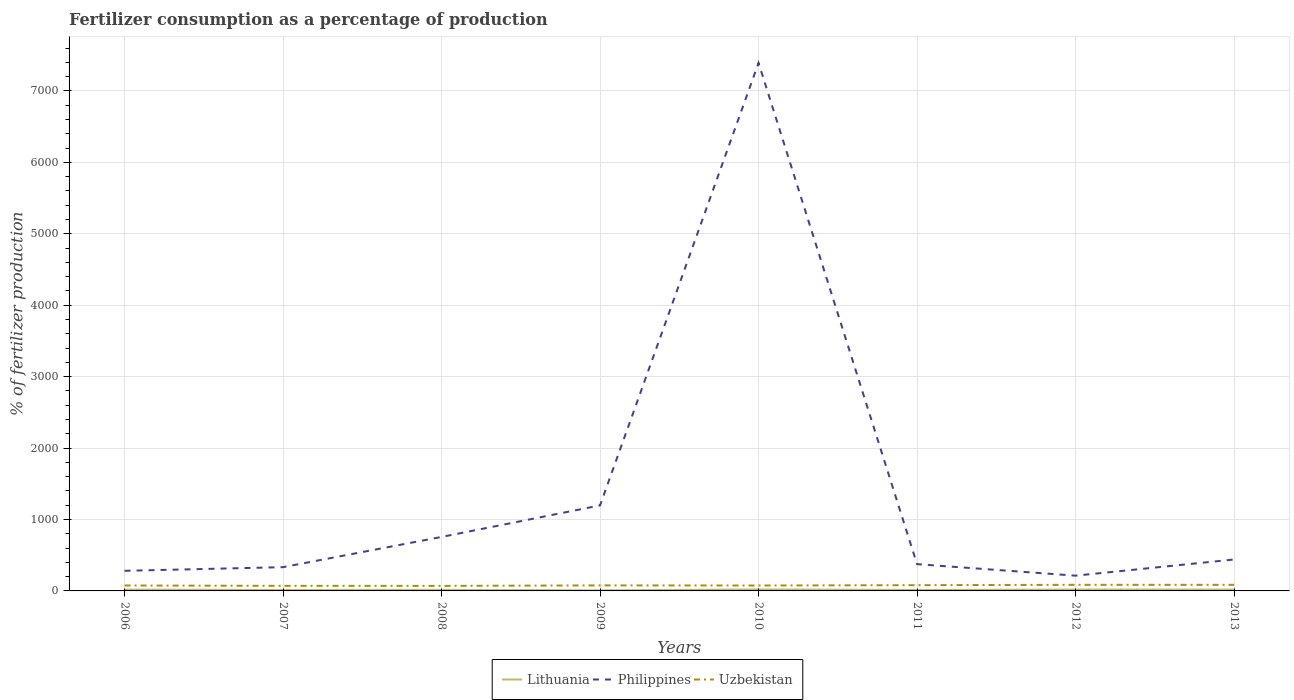How many different coloured lines are there?
Provide a short and direct response. 3. Does the line corresponding to Uzbekistan intersect with the line corresponding to Lithuania?
Keep it short and to the point. No. Is the number of lines equal to the number of legend labels?
Offer a very short reply. Yes. Across all years, what is the maximum percentage of fertilizers consumed in Lithuania?
Keep it short and to the point. 8.24. In which year was the percentage of fertilizers consumed in Philippines maximum?
Your response must be concise. 2012. What is the total percentage of fertilizers consumed in Uzbekistan in the graph?
Offer a very short reply. 0.17. What is the difference between the highest and the second highest percentage of fertilizers consumed in Lithuania?
Provide a succinct answer. 12.39. How many lines are there?
Your response must be concise. 3. How many years are there in the graph?
Ensure brevity in your answer.  8. Does the graph contain grids?
Offer a very short reply. Yes. How are the legend labels stacked?
Keep it short and to the point. Horizontal. What is the title of the graph?
Ensure brevity in your answer.  Fertilizer consumption as a percentage of production. What is the label or title of the Y-axis?
Provide a short and direct response. % of fertilizer production. What is the % of fertilizer production of Lithuania in 2006?
Ensure brevity in your answer.  18.42. What is the % of fertilizer production in Philippines in 2006?
Provide a succinct answer. 281.59. What is the % of fertilizer production in Uzbekistan in 2006?
Your answer should be compact. 76.02. What is the % of fertilizer production in Lithuania in 2007?
Your answer should be compact. 13.91. What is the % of fertilizer production in Philippines in 2007?
Make the answer very short. 332.59. What is the % of fertilizer production in Uzbekistan in 2007?
Give a very brief answer. 70.8. What is the % of fertilizer production in Lithuania in 2008?
Provide a succinct answer. 14.66. What is the % of fertilizer production of Philippines in 2008?
Your response must be concise. 755.74. What is the % of fertilizer production in Uzbekistan in 2008?
Ensure brevity in your answer.  70.18. What is the % of fertilizer production in Lithuania in 2009?
Keep it short and to the point. 8.24. What is the % of fertilizer production of Philippines in 2009?
Your answer should be compact. 1197.15. What is the % of fertilizer production in Uzbekistan in 2009?
Offer a very short reply. 77.46. What is the % of fertilizer production in Lithuania in 2010?
Your answer should be compact. 20.63. What is the % of fertilizer production in Philippines in 2010?
Offer a very short reply. 7391.18. What is the % of fertilizer production in Uzbekistan in 2010?
Give a very brief answer. 75.64. What is the % of fertilizer production in Lithuania in 2011?
Your answer should be compact. 13.61. What is the % of fertilizer production of Philippines in 2011?
Offer a very short reply. 374.92. What is the % of fertilizer production in Uzbekistan in 2011?
Provide a succinct answer. 80.55. What is the % of fertilizer production of Lithuania in 2012?
Offer a very short reply. 18.58. What is the % of fertilizer production in Philippines in 2012?
Your response must be concise. 213.56. What is the % of fertilizer production of Uzbekistan in 2012?
Offer a terse response. 85.6. What is the % of fertilizer production in Lithuania in 2013?
Provide a short and direct response. 18.16. What is the % of fertilizer production of Philippines in 2013?
Provide a short and direct response. 440.02. What is the % of fertilizer production in Uzbekistan in 2013?
Provide a succinct answer. 85.44. Across all years, what is the maximum % of fertilizer production of Lithuania?
Your response must be concise. 20.63. Across all years, what is the maximum % of fertilizer production in Philippines?
Your answer should be very brief. 7391.18. Across all years, what is the maximum % of fertilizer production of Uzbekistan?
Ensure brevity in your answer.  85.6. Across all years, what is the minimum % of fertilizer production of Lithuania?
Keep it short and to the point. 8.24. Across all years, what is the minimum % of fertilizer production in Philippines?
Your answer should be compact. 213.56. Across all years, what is the minimum % of fertilizer production in Uzbekistan?
Your answer should be very brief. 70.18. What is the total % of fertilizer production in Lithuania in the graph?
Give a very brief answer. 126.19. What is the total % of fertilizer production in Philippines in the graph?
Your response must be concise. 1.10e+04. What is the total % of fertilizer production in Uzbekistan in the graph?
Your response must be concise. 621.7. What is the difference between the % of fertilizer production of Lithuania in 2006 and that in 2007?
Your response must be concise. 4.51. What is the difference between the % of fertilizer production of Philippines in 2006 and that in 2007?
Ensure brevity in your answer.  -51. What is the difference between the % of fertilizer production of Uzbekistan in 2006 and that in 2007?
Offer a terse response. 5.21. What is the difference between the % of fertilizer production of Lithuania in 2006 and that in 2008?
Give a very brief answer. 3.76. What is the difference between the % of fertilizer production of Philippines in 2006 and that in 2008?
Offer a terse response. -474.15. What is the difference between the % of fertilizer production of Uzbekistan in 2006 and that in 2008?
Your answer should be compact. 5.83. What is the difference between the % of fertilizer production of Lithuania in 2006 and that in 2009?
Your answer should be very brief. 10.18. What is the difference between the % of fertilizer production of Philippines in 2006 and that in 2009?
Your response must be concise. -915.56. What is the difference between the % of fertilizer production of Uzbekistan in 2006 and that in 2009?
Your answer should be compact. -1.45. What is the difference between the % of fertilizer production of Lithuania in 2006 and that in 2010?
Keep it short and to the point. -2.21. What is the difference between the % of fertilizer production of Philippines in 2006 and that in 2010?
Give a very brief answer. -7109.59. What is the difference between the % of fertilizer production in Uzbekistan in 2006 and that in 2010?
Make the answer very short. 0.37. What is the difference between the % of fertilizer production of Lithuania in 2006 and that in 2011?
Give a very brief answer. 4.81. What is the difference between the % of fertilizer production in Philippines in 2006 and that in 2011?
Offer a terse response. -93.33. What is the difference between the % of fertilizer production in Uzbekistan in 2006 and that in 2011?
Your answer should be very brief. -4.54. What is the difference between the % of fertilizer production in Lithuania in 2006 and that in 2012?
Offer a very short reply. -0.16. What is the difference between the % of fertilizer production of Philippines in 2006 and that in 2012?
Provide a succinct answer. 68.03. What is the difference between the % of fertilizer production in Uzbekistan in 2006 and that in 2012?
Provide a succinct answer. -9.59. What is the difference between the % of fertilizer production in Lithuania in 2006 and that in 2013?
Ensure brevity in your answer.  0.26. What is the difference between the % of fertilizer production in Philippines in 2006 and that in 2013?
Provide a succinct answer. -158.43. What is the difference between the % of fertilizer production in Uzbekistan in 2006 and that in 2013?
Provide a short and direct response. -9.42. What is the difference between the % of fertilizer production of Lithuania in 2007 and that in 2008?
Offer a very short reply. -0.75. What is the difference between the % of fertilizer production of Philippines in 2007 and that in 2008?
Provide a succinct answer. -423.15. What is the difference between the % of fertilizer production of Uzbekistan in 2007 and that in 2008?
Provide a succinct answer. 0.62. What is the difference between the % of fertilizer production of Lithuania in 2007 and that in 2009?
Keep it short and to the point. 5.67. What is the difference between the % of fertilizer production in Philippines in 2007 and that in 2009?
Keep it short and to the point. -864.56. What is the difference between the % of fertilizer production in Uzbekistan in 2007 and that in 2009?
Provide a succinct answer. -6.66. What is the difference between the % of fertilizer production in Lithuania in 2007 and that in 2010?
Give a very brief answer. -6.72. What is the difference between the % of fertilizer production of Philippines in 2007 and that in 2010?
Provide a succinct answer. -7058.59. What is the difference between the % of fertilizer production of Uzbekistan in 2007 and that in 2010?
Provide a short and direct response. -4.84. What is the difference between the % of fertilizer production of Lithuania in 2007 and that in 2011?
Offer a very short reply. 0.3. What is the difference between the % of fertilizer production of Philippines in 2007 and that in 2011?
Offer a terse response. -42.33. What is the difference between the % of fertilizer production of Uzbekistan in 2007 and that in 2011?
Keep it short and to the point. -9.75. What is the difference between the % of fertilizer production of Lithuania in 2007 and that in 2012?
Offer a terse response. -4.67. What is the difference between the % of fertilizer production in Philippines in 2007 and that in 2012?
Give a very brief answer. 119.03. What is the difference between the % of fertilizer production in Uzbekistan in 2007 and that in 2012?
Offer a very short reply. -14.8. What is the difference between the % of fertilizer production of Lithuania in 2007 and that in 2013?
Provide a short and direct response. -4.25. What is the difference between the % of fertilizer production of Philippines in 2007 and that in 2013?
Your answer should be very brief. -107.43. What is the difference between the % of fertilizer production in Uzbekistan in 2007 and that in 2013?
Make the answer very short. -14.63. What is the difference between the % of fertilizer production in Lithuania in 2008 and that in 2009?
Your answer should be compact. 6.43. What is the difference between the % of fertilizer production of Philippines in 2008 and that in 2009?
Keep it short and to the point. -441.41. What is the difference between the % of fertilizer production of Uzbekistan in 2008 and that in 2009?
Your response must be concise. -7.28. What is the difference between the % of fertilizer production of Lithuania in 2008 and that in 2010?
Your answer should be compact. -5.97. What is the difference between the % of fertilizer production in Philippines in 2008 and that in 2010?
Your answer should be very brief. -6635.44. What is the difference between the % of fertilizer production in Uzbekistan in 2008 and that in 2010?
Offer a terse response. -5.46. What is the difference between the % of fertilizer production of Lithuania in 2008 and that in 2011?
Offer a terse response. 1.05. What is the difference between the % of fertilizer production of Philippines in 2008 and that in 2011?
Provide a short and direct response. 380.82. What is the difference between the % of fertilizer production of Uzbekistan in 2008 and that in 2011?
Keep it short and to the point. -10.37. What is the difference between the % of fertilizer production in Lithuania in 2008 and that in 2012?
Ensure brevity in your answer.  -3.92. What is the difference between the % of fertilizer production of Philippines in 2008 and that in 2012?
Offer a very short reply. 542.18. What is the difference between the % of fertilizer production of Uzbekistan in 2008 and that in 2012?
Offer a very short reply. -15.42. What is the difference between the % of fertilizer production of Lithuania in 2008 and that in 2013?
Provide a succinct answer. -3.49. What is the difference between the % of fertilizer production of Philippines in 2008 and that in 2013?
Keep it short and to the point. 315.72. What is the difference between the % of fertilizer production in Uzbekistan in 2008 and that in 2013?
Your answer should be very brief. -15.25. What is the difference between the % of fertilizer production in Lithuania in 2009 and that in 2010?
Give a very brief answer. -12.39. What is the difference between the % of fertilizer production of Philippines in 2009 and that in 2010?
Provide a succinct answer. -6194.03. What is the difference between the % of fertilizer production in Uzbekistan in 2009 and that in 2010?
Your answer should be very brief. 1.82. What is the difference between the % of fertilizer production in Lithuania in 2009 and that in 2011?
Your answer should be very brief. -5.37. What is the difference between the % of fertilizer production in Philippines in 2009 and that in 2011?
Your answer should be compact. 822.23. What is the difference between the % of fertilizer production of Uzbekistan in 2009 and that in 2011?
Your response must be concise. -3.09. What is the difference between the % of fertilizer production of Lithuania in 2009 and that in 2012?
Provide a succinct answer. -10.34. What is the difference between the % of fertilizer production in Philippines in 2009 and that in 2012?
Provide a short and direct response. 983.59. What is the difference between the % of fertilizer production of Uzbekistan in 2009 and that in 2012?
Ensure brevity in your answer.  -8.14. What is the difference between the % of fertilizer production in Lithuania in 2009 and that in 2013?
Provide a short and direct response. -9.92. What is the difference between the % of fertilizer production of Philippines in 2009 and that in 2013?
Ensure brevity in your answer.  757.13. What is the difference between the % of fertilizer production of Uzbekistan in 2009 and that in 2013?
Offer a terse response. -7.97. What is the difference between the % of fertilizer production in Lithuania in 2010 and that in 2011?
Ensure brevity in your answer.  7.02. What is the difference between the % of fertilizer production in Philippines in 2010 and that in 2011?
Offer a terse response. 7016.26. What is the difference between the % of fertilizer production of Uzbekistan in 2010 and that in 2011?
Your response must be concise. -4.91. What is the difference between the % of fertilizer production in Lithuania in 2010 and that in 2012?
Offer a very short reply. 2.05. What is the difference between the % of fertilizer production of Philippines in 2010 and that in 2012?
Provide a short and direct response. 7177.62. What is the difference between the % of fertilizer production of Uzbekistan in 2010 and that in 2012?
Make the answer very short. -9.96. What is the difference between the % of fertilizer production in Lithuania in 2010 and that in 2013?
Keep it short and to the point. 2.47. What is the difference between the % of fertilizer production in Philippines in 2010 and that in 2013?
Your answer should be compact. 6951.16. What is the difference between the % of fertilizer production of Uzbekistan in 2010 and that in 2013?
Offer a very short reply. -9.8. What is the difference between the % of fertilizer production in Lithuania in 2011 and that in 2012?
Your response must be concise. -4.97. What is the difference between the % of fertilizer production in Philippines in 2011 and that in 2012?
Your answer should be compact. 161.36. What is the difference between the % of fertilizer production of Uzbekistan in 2011 and that in 2012?
Ensure brevity in your answer.  -5.05. What is the difference between the % of fertilizer production in Lithuania in 2011 and that in 2013?
Make the answer very short. -4.55. What is the difference between the % of fertilizer production in Philippines in 2011 and that in 2013?
Offer a very short reply. -65.1. What is the difference between the % of fertilizer production of Uzbekistan in 2011 and that in 2013?
Make the answer very short. -4.88. What is the difference between the % of fertilizer production in Lithuania in 2012 and that in 2013?
Make the answer very short. 0.42. What is the difference between the % of fertilizer production in Philippines in 2012 and that in 2013?
Ensure brevity in your answer.  -226.46. What is the difference between the % of fertilizer production of Uzbekistan in 2012 and that in 2013?
Your answer should be compact. 0.17. What is the difference between the % of fertilizer production of Lithuania in 2006 and the % of fertilizer production of Philippines in 2007?
Keep it short and to the point. -314.17. What is the difference between the % of fertilizer production in Lithuania in 2006 and the % of fertilizer production in Uzbekistan in 2007?
Your response must be concise. -52.38. What is the difference between the % of fertilizer production in Philippines in 2006 and the % of fertilizer production in Uzbekistan in 2007?
Offer a terse response. 210.79. What is the difference between the % of fertilizer production of Lithuania in 2006 and the % of fertilizer production of Philippines in 2008?
Ensure brevity in your answer.  -737.32. What is the difference between the % of fertilizer production in Lithuania in 2006 and the % of fertilizer production in Uzbekistan in 2008?
Offer a terse response. -51.77. What is the difference between the % of fertilizer production of Philippines in 2006 and the % of fertilizer production of Uzbekistan in 2008?
Offer a terse response. 211.4. What is the difference between the % of fertilizer production in Lithuania in 2006 and the % of fertilizer production in Philippines in 2009?
Make the answer very short. -1178.73. What is the difference between the % of fertilizer production in Lithuania in 2006 and the % of fertilizer production in Uzbekistan in 2009?
Offer a very short reply. -59.05. What is the difference between the % of fertilizer production of Philippines in 2006 and the % of fertilizer production of Uzbekistan in 2009?
Provide a short and direct response. 204.12. What is the difference between the % of fertilizer production of Lithuania in 2006 and the % of fertilizer production of Philippines in 2010?
Ensure brevity in your answer.  -7372.76. What is the difference between the % of fertilizer production in Lithuania in 2006 and the % of fertilizer production in Uzbekistan in 2010?
Provide a short and direct response. -57.22. What is the difference between the % of fertilizer production of Philippines in 2006 and the % of fertilizer production of Uzbekistan in 2010?
Give a very brief answer. 205.95. What is the difference between the % of fertilizer production in Lithuania in 2006 and the % of fertilizer production in Philippines in 2011?
Provide a succinct answer. -356.5. What is the difference between the % of fertilizer production in Lithuania in 2006 and the % of fertilizer production in Uzbekistan in 2011?
Your response must be concise. -62.13. What is the difference between the % of fertilizer production in Philippines in 2006 and the % of fertilizer production in Uzbekistan in 2011?
Ensure brevity in your answer.  201.04. What is the difference between the % of fertilizer production of Lithuania in 2006 and the % of fertilizer production of Philippines in 2012?
Make the answer very short. -195.14. What is the difference between the % of fertilizer production of Lithuania in 2006 and the % of fertilizer production of Uzbekistan in 2012?
Keep it short and to the point. -67.19. What is the difference between the % of fertilizer production in Philippines in 2006 and the % of fertilizer production in Uzbekistan in 2012?
Offer a very short reply. 195.98. What is the difference between the % of fertilizer production of Lithuania in 2006 and the % of fertilizer production of Philippines in 2013?
Offer a very short reply. -421.6. What is the difference between the % of fertilizer production of Lithuania in 2006 and the % of fertilizer production of Uzbekistan in 2013?
Make the answer very short. -67.02. What is the difference between the % of fertilizer production in Philippines in 2006 and the % of fertilizer production in Uzbekistan in 2013?
Offer a terse response. 196.15. What is the difference between the % of fertilizer production in Lithuania in 2007 and the % of fertilizer production in Philippines in 2008?
Offer a terse response. -741.83. What is the difference between the % of fertilizer production of Lithuania in 2007 and the % of fertilizer production of Uzbekistan in 2008?
Offer a terse response. -56.27. What is the difference between the % of fertilizer production in Philippines in 2007 and the % of fertilizer production in Uzbekistan in 2008?
Make the answer very short. 262.4. What is the difference between the % of fertilizer production in Lithuania in 2007 and the % of fertilizer production in Philippines in 2009?
Make the answer very short. -1183.24. What is the difference between the % of fertilizer production in Lithuania in 2007 and the % of fertilizer production in Uzbekistan in 2009?
Give a very brief answer. -63.55. What is the difference between the % of fertilizer production in Philippines in 2007 and the % of fertilizer production in Uzbekistan in 2009?
Provide a succinct answer. 255.12. What is the difference between the % of fertilizer production of Lithuania in 2007 and the % of fertilizer production of Philippines in 2010?
Provide a short and direct response. -7377.27. What is the difference between the % of fertilizer production of Lithuania in 2007 and the % of fertilizer production of Uzbekistan in 2010?
Your answer should be very brief. -61.73. What is the difference between the % of fertilizer production in Philippines in 2007 and the % of fertilizer production in Uzbekistan in 2010?
Provide a succinct answer. 256.95. What is the difference between the % of fertilizer production in Lithuania in 2007 and the % of fertilizer production in Philippines in 2011?
Ensure brevity in your answer.  -361.01. What is the difference between the % of fertilizer production in Lithuania in 2007 and the % of fertilizer production in Uzbekistan in 2011?
Keep it short and to the point. -66.64. What is the difference between the % of fertilizer production in Philippines in 2007 and the % of fertilizer production in Uzbekistan in 2011?
Keep it short and to the point. 252.03. What is the difference between the % of fertilizer production of Lithuania in 2007 and the % of fertilizer production of Philippines in 2012?
Keep it short and to the point. -199.65. What is the difference between the % of fertilizer production of Lithuania in 2007 and the % of fertilizer production of Uzbekistan in 2012?
Your answer should be compact. -71.69. What is the difference between the % of fertilizer production in Philippines in 2007 and the % of fertilizer production in Uzbekistan in 2012?
Keep it short and to the point. 246.98. What is the difference between the % of fertilizer production in Lithuania in 2007 and the % of fertilizer production in Philippines in 2013?
Offer a terse response. -426.11. What is the difference between the % of fertilizer production in Lithuania in 2007 and the % of fertilizer production in Uzbekistan in 2013?
Your answer should be very brief. -71.53. What is the difference between the % of fertilizer production in Philippines in 2007 and the % of fertilizer production in Uzbekistan in 2013?
Offer a terse response. 247.15. What is the difference between the % of fertilizer production of Lithuania in 2008 and the % of fertilizer production of Philippines in 2009?
Offer a terse response. -1182.49. What is the difference between the % of fertilizer production in Lithuania in 2008 and the % of fertilizer production in Uzbekistan in 2009?
Offer a very short reply. -62.8. What is the difference between the % of fertilizer production of Philippines in 2008 and the % of fertilizer production of Uzbekistan in 2009?
Your answer should be very brief. 678.28. What is the difference between the % of fertilizer production of Lithuania in 2008 and the % of fertilizer production of Philippines in 2010?
Offer a terse response. -7376.52. What is the difference between the % of fertilizer production of Lithuania in 2008 and the % of fertilizer production of Uzbekistan in 2010?
Offer a very short reply. -60.98. What is the difference between the % of fertilizer production in Philippines in 2008 and the % of fertilizer production in Uzbekistan in 2010?
Your answer should be compact. 680.1. What is the difference between the % of fertilizer production in Lithuania in 2008 and the % of fertilizer production in Philippines in 2011?
Provide a short and direct response. -360.26. What is the difference between the % of fertilizer production in Lithuania in 2008 and the % of fertilizer production in Uzbekistan in 2011?
Provide a short and direct response. -65.89. What is the difference between the % of fertilizer production in Philippines in 2008 and the % of fertilizer production in Uzbekistan in 2011?
Ensure brevity in your answer.  675.19. What is the difference between the % of fertilizer production in Lithuania in 2008 and the % of fertilizer production in Philippines in 2012?
Provide a short and direct response. -198.9. What is the difference between the % of fertilizer production in Lithuania in 2008 and the % of fertilizer production in Uzbekistan in 2012?
Provide a succinct answer. -70.94. What is the difference between the % of fertilizer production in Philippines in 2008 and the % of fertilizer production in Uzbekistan in 2012?
Your response must be concise. 670.14. What is the difference between the % of fertilizer production in Lithuania in 2008 and the % of fertilizer production in Philippines in 2013?
Your answer should be compact. -425.36. What is the difference between the % of fertilizer production in Lithuania in 2008 and the % of fertilizer production in Uzbekistan in 2013?
Your response must be concise. -70.78. What is the difference between the % of fertilizer production of Philippines in 2008 and the % of fertilizer production of Uzbekistan in 2013?
Your answer should be very brief. 670.3. What is the difference between the % of fertilizer production in Lithuania in 2009 and the % of fertilizer production in Philippines in 2010?
Make the answer very short. -7382.94. What is the difference between the % of fertilizer production in Lithuania in 2009 and the % of fertilizer production in Uzbekistan in 2010?
Provide a succinct answer. -67.41. What is the difference between the % of fertilizer production in Philippines in 2009 and the % of fertilizer production in Uzbekistan in 2010?
Your answer should be compact. 1121.51. What is the difference between the % of fertilizer production of Lithuania in 2009 and the % of fertilizer production of Philippines in 2011?
Make the answer very short. -366.68. What is the difference between the % of fertilizer production in Lithuania in 2009 and the % of fertilizer production in Uzbekistan in 2011?
Provide a succinct answer. -72.32. What is the difference between the % of fertilizer production in Philippines in 2009 and the % of fertilizer production in Uzbekistan in 2011?
Ensure brevity in your answer.  1116.6. What is the difference between the % of fertilizer production in Lithuania in 2009 and the % of fertilizer production in Philippines in 2012?
Give a very brief answer. -205.33. What is the difference between the % of fertilizer production in Lithuania in 2009 and the % of fertilizer production in Uzbekistan in 2012?
Your response must be concise. -77.37. What is the difference between the % of fertilizer production in Philippines in 2009 and the % of fertilizer production in Uzbekistan in 2012?
Give a very brief answer. 1111.54. What is the difference between the % of fertilizer production in Lithuania in 2009 and the % of fertilizer production in Philippines in 2013?
Your answer should be compact. -431.78. What is the difference between the % of fertilizer production in Lithuania in 2009 and the % of fertilizer production in Uzbekistan in 2013?
Offer a terse response. -77.2. What is the difference between the % of fertilizer production in Philippines in 2009 and the % of fertilizer production in Uzbekistan in 2013?
Provide a succinct answer. 1111.71. What is the difference between the % of fertilizer production in Lithuania in 2010 and the % of fertilizer production in Philippines in 2011?
Your answer should be compact. -354.29. What is the difference between the % of fertilizer production in Lithuania in 2010 and the % of fertilizer production in Uzbekistan in 2011?
Ensure brevity in your answer.  -59.92. What is the difference between the % of fertilizer production of Philippines in 2010 and the % of fertilizer production of Uzbekistan in 2011?
Give a very brief answer. 7310.63. What is the difference between the % of fertilizer production in Lithuania in 2010 and the % of fertilizer production in Philippines in 2012?
Your answer should be very brief. -192.93. What is the difference between the % of fertilizer production in Lithuania in 2010 and the % of fertilizer production in Uzbekistan in 2012?
Your answer should be compact. -64.98. What is the difference between the % of fertilizer production in Philippines in 2010 and the % of fertilizer production in Uzbekistan in 2012?
Make the answer very short. 7305.57. What is the difference between the % of fertilizer production of Lithuania in 2010 and the % of fertilizer production of Philippines in 2013?
Ensure brevity in your answer.  -419.39. What is the difference between the % of fertilizer production of Lithuania in 2010 and the % of fertilizer production of Uzbekistan in 2013?
Provide a succinct answer. -64.81. What is the difference between the % of fertilizer production in Philippines in 2010 and the % of fertilizer production in Uzbekistan in 2013?
Provide a succinct answer. 7305.74. What is the difference between the % of fertilizer production in Lithuania in 2011 and the % of fertilizer production in Philippines in 2012?
Provide a short and direct response. -199.95. What is the difference between the % of fertilizer production in Lithuania in 2011 and the % of fertilizer production in Uzbekistan in 2012?
Offer a terse response. -71.99. What is the difference between the % of fertilizer production in Philippines in 2011 and the % of fertilizer production in Uzbekistan in 2012?
Offer a terse response. 289.31. What is the difference between the % of fertilizer production of Lithuania in 2011 and the % of fertilizer production of Philippines in 2013?
Offer a terse response. -426.41. What is the difference between the % of fertilizer production of Lithuania in 2011 and the % of fertilizer production of Uzbekistan in 2013?
Keep it short and to the point. -71.83. What is the difference between the % of fertilizer production of Philippines in 2011 and the % of fertilizer production of Uzbekistan in 2013?
Offer a terse response. 289.48. What is the difference between the % of fertilizer production of Lithuania in 2012 and the % of fertilizer production of Philippines in 2013?
Your response must be concise. -421.44. What is the difference between the % of fertilizer production in Lithuania in 2012 and the % of fertilizer production in Uzbekistan in 2013?
Your answer should be very brief. -66.86. What is the difference between the % of fertilizer production in Philippines in 2012 and the % of fertilizer production in Uzbekistan in 2013?
Your response must be concise. 128.12. What is the average % of fertilizer production in Lithuania per year?
Keep it short and to the point. 15.77. What is the average % of fertilizer production in Philippines per year?
Make the answer very short. 1373.34. What is the average % of fertilizer production of Uzbekistan per year?
Ensure brevity in your answer.  77.71. In the year 2006, what is the difference between the % of fertilizer production in Lithuania and % of fertilizer production in Philippines?
Give a very brief answer. -263.17. In the year 2006, what is the difference between the % of fertilizer production in Lithuania and % of fertilizer production in Uzbekistan?
Your answer should be very brief. -57.6. In the year 2006, what is the difference between the % of fertilizer production in Philippines and % of fertilizer production in Uzbekistan?
Your answer should be compact. 205.57. In the year 2007, what is the difference between the % of fertilizer production in Lithuania and % of fertilizer production in Philippines?
Give a very brief answer. -318.68. In the year 2007, what is the difference between the % of fertilizer production in Lithuania and % of fertilizer production in Uzbekistan?
Make the answer very short. -56.89. In the year 2007, what is the difference between the % of fertilizer production of Philippines and % of fertilizer production of Uzbekistan?
Keep it short and to the point. 261.78. In the year 2008, what is the difference between the % of fertilizer production in Lithuania and % of fertilizer production in Philippines?
Your answer should be very brief. -741.08. In the year 2008, what is the difference between the % of fertilizer production of Lithuania and % of fertilizer production of Uzbekistan?
Ensure brevity in your answer.  -55.52. In the year 2008, what is the difference between the % of fertilizer production in Philippines and % of fertilizer production in Uzbekistan?
Make the answer very short. 685.56. In the year 2009, what is the difference between the % of fertilizer production in Lithuania and % of fertilizer production in Philippines?
Keep it short and to the point. -1188.91. In the year 2009, what is the difference between the % of fertilizer production in Lithuania and % of fertilizer production in Uzbekistan?
Provide a short and direct response. -69.23. In the year 2009, what is the difference between the % of fertilizer production of Philippines and % of fertilizer production of Uzbekistan?
Ensure brevity in your answer.  1119.68. In the year 2010, what is the difference between the % of fertilizer production in Lithuania and % of fertilizer production in Philippines?
Your answer should be very brief. -7370.55. In the year 2010, what is the difference between the % of fertilizer production of Lithuania and % of fertilizer production of Uzbekistan?
Make the answer very short. -55.01. In the year 2010, what is the difference between the % of fertilizer production of Philippines and % of fertilizer production of Uzbekistan?
Give a very brief answer. 7315.54. In the year 2011, what is the difference between the % of fertilizer production of Lithuania and % of fertilizer production of Philippines?
Provide a short and direct response. -361.31. In the year 2011, what is the difference between the % of fertilizer production of Lithuania and % of fertilizer production of Uzbekistan?
Provide a succinct answer. -66.94. In the year 2011, what is the difference between the % of fertilizer production in Philippines and % of fertilizer production in Uzbekistan?
Your answer should be compact. 294.37. In the year 2012, what is the difference between the % of fertilizer production in Lithuania and % of fertilizer production in Philippines?
Ensure brevity in your answer.  -194.98. In the year 2012, what is the difference between the % of fertilizer production of Lithuania and % of fertilizer production of Uzbekistan?
Your response must be concise. -67.03. In the year 2012, what is the difference between the % of fertilizer production of Philippines and % of fertilizer production of Uzbekistan?
Your answer should be compact. 127.96. In the year 2013, what is the difference between the % of fertilizer production of Lithuania and % of fertilizer production of Philippines?
Provide a short and direct response. -421.86. In the year 2013, what is the difference between the % of fertilizer production in Lithuania and % of fertilizer production in Uzbekistan?
Give a very brief answer. -67.28. In the year 2013, what is the difference between the % of fertilizer production in Philippines and % of fertilizer production in Uzbekistan?
Keep it short and to the point. 354.58. What is the ratio of the % of fertilizer production in Lithuania in 2006 to that in 2007?
Your response must be concise. 1.32. What is the ratio of the % of fertilizer production in Philippines in 2006 to that in 2007?
Keep it short and to the point. 0.85. What is the ratio of the % of fertilizer production in Uzbekistan in 2006 to that in 2007?
Provide a short and direct response. 1.07. What is the ratio of the % of fertilizer production in Lithuania in 2006 to that in 2008?
Ensure brevity in your answer.  1.26. What is the ratio of the % of fertilizer production in Philippines in 2006 to that in 2008?
Give a very brief answer. 0.37. What is the ratio of the % of fertilizer production in Uzbekistan in 2006 to that in 2008?
Ensure brevity in your answer.  1.08. What is the ratio of the % of fertilizer production of Lithuania in 2006 to that in 2009?
Your response must be concise. 2.24. What is the ratio of the % of fertilizer production in Philippines in 2006 to that in 2009?
Make the answer very short. 0.24. What is the ratio of the % of fertilizer production of Uzbekistan in 2006 to that in 2009?
Offer a very short reply. 0.98. What is the ratio of the % of fertilizer production in Lithuania in 2006 to that in 2010?
Make the answer very short. 0.89. What is the ratio of the % of fertilizer production in Philippines in 2006 to that in 2010?
Provide a short and direct response. 0.04. What is the ratio of the % of fertilizer production of Uzbekistan in 2006 to that in 2010?
Offer a terse response. 1. What is the ratio of the % of fertilizer production of Lithuania in 2006 to that in 2011?
Your answer should be compact. 1.35. What is the ratio of the % of fertilizer production in Philippines in 2006 to that in 2011?
Make the answer very short. 0.75. What is the ratio of the % of fertilizer production in Uzbekistan in 2006 to that in 2011?
Offer a very short reply. 0.94. What is the ratio of the % of fertilizer production in Lithuania in 2006 to that in 2012?
Your answer should be very brief. 0.99. What is the ratio of the % of fertilizer production in Philippines in 2006 to that in 2012?
Your answer should be compact. 1.32. What is the ratio of the % of fertilizer production in Uzbekistan in 2006 to that in 2012?
Offer a terse response. 0.89. What is the ratio of the % of fertilizer production of Lithuania in 2006 to that in 2013?
Your response must be concise. 1.01. What is the ratio of the % of fertilizer production of Philippines in 2006 to that in 2013?
Your response must be concise. 0.64. What is the ratio of the % of fertilizer production in Uzbekistan in 2006 to that in 2013?
Make the answer very short. 0.89. What is the ratio of the % of fertilizer production of Lithuania in 2007 to that in 2008?
Offer a terse response. 0.95. What is the ratio of the % of fertilizer production of Philippines in 2007 to that in 2008?
Keep it short and to the point. 0.44. What is the ratio of the % of fertilizer production of Uzbekistan in 2007 to that in 2008?
Provide a short and direct response. 1.01. What is the ratio of the % of fertilizer production in Lithuania in 2007 to that in 2009?
Provide a succinct answer. 1.69. What is the ratio of the % of fertilizer production of Philippines in 2007 to that in 2009?
Your answer should be compact. 0.28. What is the ratio of the % of fertilizer production in Uzbekistan in 2007 to that in 2009?
Offer a very short reply. 0.91. What is the ratio of the % of fertilizer production of Lithuania in 2007 to that in 2010?
Ensure brevity in your answer.  0.67. What is the ratio of the % of fertilizer production in Philippines in 2007 to that in 2010?
Your response must be concise. 0.04. What is the ratio of the % of fertilizer production in Uzbekistan in 2007 to that in 2010?
Your answer should be compact. 0.94. What is the ratio of the % of fertilizer production in Lithuania in 2007 to that in 2011?
Offer a very short reply. 1.02. What is the ratio of the % of fertilizer production of Philippines in 2007 to that in 2011?
Your response must be concise. 0.89. What is the ratio of the % of fertilizer production of Uzbekistan in 2007 to that in 2011?
Your answer should be very brief. 0.88. What is the ratio of the % of fertilizer production in Lithuania in 2007 to that in 2012?
Offer a very short reply. 0.75. What is the ratio of the % of fertilizer production of Philippines in 2007 to that in 2012?
Your response must be concise. 1.56. What is the ratio of the % of fertilizer production of Uzbekistan in 2007 to that in 2012?
Offer a very short reply. 0.83. What is the ratio of the % of fertilizer production of Lithuania in 2007 to that in 2013?
Ensure brevity in your answer.  0.77. What is the ratio of the % of fertilizer production in Philippines in 2007 to that in 2013?
Provide a short and direct response. 0.76. What is the ratio of the % of fertilizer production in Uzbekistan in 2007 to that in 2013?
Your response must be concise. 0.83. What is the ratio of the % of fertilizer production in Lithuania in 2008 to that in 2009?
Your answer should be very brief. 1.78. What is the ratio of the % of fertilizer production in Philippines in 2008 to that in 2009?
Offer a very short reply. 0.63. What is the ratio of the % of fertilizer production in Uzbekistan in 2008 to that in 2009?
Provide a short and direct response. 0.91. What is the ratio of the % of fertilizer production of Lithuania in 2008 to that in 2010?
Make the answer very short. 0.71. What is the ratio of the % of fertilizer production of Philippines in 2008 to that in 2010?
Offer a very short reply. 0.1. What is the ratio of the % of fertilizer production of Uzbekistan in 2008 to that in 2010?
Your answer should be very brief. 0.93. What is the ratio of the % of fertilizer production of Lithuania in 2008 to that in 2011?
Provide a short and direct response. 1.08. What is the ratio of the % of fertilizer production of Philippines in 2008 to that in 2011?
Keep it short and to the point. 2.02. What is the ratio of the % of fertilizer production in Uzbekistan in 2008 to that in 2011?
Ensure brevity in your answer.  0.87. What is the ratio of the % of fertilizer production in Lithuania in 2008 to that in 2012?
Make the answer very short. 0.79. What is the ratio of the % of fertilizer production of Philippines in 2008 to that in 2012?
Your answer should be very brief. 3.54. What is the ratio of the % of fertilizer production of Uzbekistan in 2008 to that in 2012?
Make the answer very short. 0.82. What is the ratio of the % of fertilizer production of Lithuania in 2008 to that in 2013?
Give a very brief answer. 0.81. What is the ratio of the % of fertilizer production of Philippines in 2008 to that in 2013?
Your answer should be compact. 1.72. What is the ratio of the % of fertilizer production in Uzbekistan in 2008 to that in 2013?
Offer a very short reply. 0.82. What is the ratio of the % of fertilizer production of Lithuania in 2009 to that in 2010?
Your response must be concise. 0.4. What is the ratio of the % of fertilizer production in Philippines in 2009 to that in 2010?
Your answer should be very brief. 0.16. What is the ratio of the % of fertilizer production in Uzbekistan in 2009 to that in 2010?
Provide a short and direct response. 1.02. What is the ratio of the % of fertilizer production in Lithuania in 2009 to that in 2011?
Your answer should be compact. 0.61. What is the ratio of the % of fertilizer production in Philippines in 2009 to that in 2011?
Your answer should be compact. 3.19. What is the ratio of the % of fertilizer production of Uzbekistan in 2009 to that in 2011?
Ensure brevity in your answer.  0.96. What is the ratio of the % of fertilizer production of Lithuania in 2009 to that in 2012?
Offer a terse response. 0.44. What is the ratio of the % of fertilizer production of Philippines in 2009 to that in 2012?
Your answer should be very brief. 5.61. What is the ratio of the % of fertilizer production of Uzbekistan in 2009 to that in 2012?
Your answer should be compact. 0.9. What is the ratio of the % of fertilizer production in Lithuania in 2009 to that in 2013?
Ensure brevity in your answer.  0.45. What is the ratio of the % of fertilizer production of Philippines in 2009 to that in 2013?
Ensure brevity in your answer.  2.72. What is the ratio of the % of fertilizer production of Uzbekistan in 2009 to that in 2013?
Provide a short and direct response. 0.91. What is the ratio of the % of fertilizer production of Lithuania in 2010 to that in 2011?
Your response must be concise. 1.52. What is the ratio of the % of fertilizer production of Philippines in 2010 to that in 2011?
Keep it short and to the point. 19.71. What is the ratio of the % of fertilizer production in Uzbekistan in 2010 to that in 2011?
Your answer should be very brief. 0.94. What is the ratio of the % of fertilizer production in Lithuania in 2010 to that in 2012?
Your response must be concise. 1.11. What is the ratio of the % of fertilizer production in Philippines in 2010 to that in 2012?
Offer a very short reply. 34.61. What is the ratio of the % of fertilizer production in Uzbekistan in 2010 to that in 2012?
Your response must be concise. 0.88. What is the ratio of the % of fertilizer production in Lithuania in 2010 to that in 2013?
Provide a short and direct response. 1.14. What is the ratio of the % of fertilizer production of Philippines in 2010 to that in 2013?
Provide a short and direct response. 16.8. What is the ratio of the % of fertilizer production of Uzbekistan in 2010 to that in 2013?
Ensure brevity in your answer.  0.89. What is the ratio of the % of fertilizer production in Lithuania in 2011 to that in 2012?
Offer a very short reply. 0.73. What is the ratio of the % of fertilizer production in Philippines in 2011 to that in 2012?
Ensure brevity in your answer.  1.76. What is the ratio of the % of fertilizer production of Uzbekistan in 2011 to that in 2012?
Offer a terse response. 0.94. What is the ratio of the % of fertilizer production in Lithuania in 2011 to that in 2013?
Your answer should be very brief. 0.75. What is the ratio of the % of fertilizer production in Philippines in 2011 to that in 2013?
Provide a short and direct response. 0.85. What is the ratio of the % of fertilizer production in Uzbekistan in 2011 to that in 2013?
Your answer should be very brief. 0.94. What is the ratio of the % of fertilizer production in Lithuania in 2012 to that in 2013?
Offer a terse response. 1.02. What is the ratio of the % of fertilizer production of Philippines in 2012 to that in 2013?
Offer a terse response. 0.49. What is the ratio of the % of fertilizer production of Uzbekistan in 2012 to that in 2013?
Provide a succinct answer. 1. What is the difference between the highest and the second highest % of fertilizer production in Lithuania?
Provide a succinct answer. 2.05. What is the difference between the highest and the second highest % of fertilizer production of Philippines?
Your answer should be compact. 6194.03. What is the difference between the highest and the second highest % of fertilizer production in Uzbekistan?
Make the answer very short. 0.17. What is the difference between the highest and the lowest % of fertilizer production of Lithuania?
Offer a terse response. 12.39. What is the difference between the highest and the lowest % of fertilizer production in Philippines?
Make the answer very short. 7177.62. What is the difference between the highest and the lowest % of fertilizer production of Uzbekistan?
Provide a short and direct response. 15.42. 